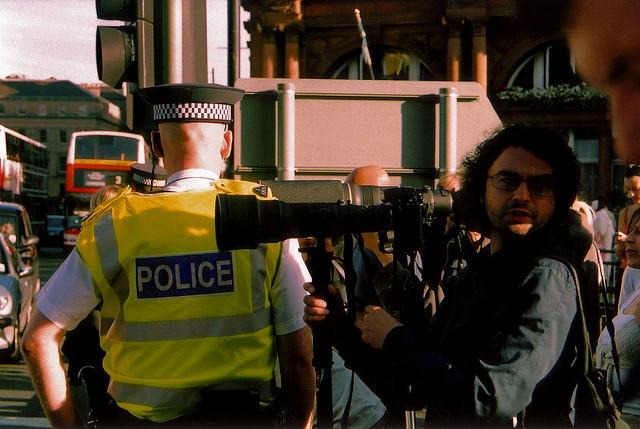What is the occupation of the man wearing a black coat? photographer 